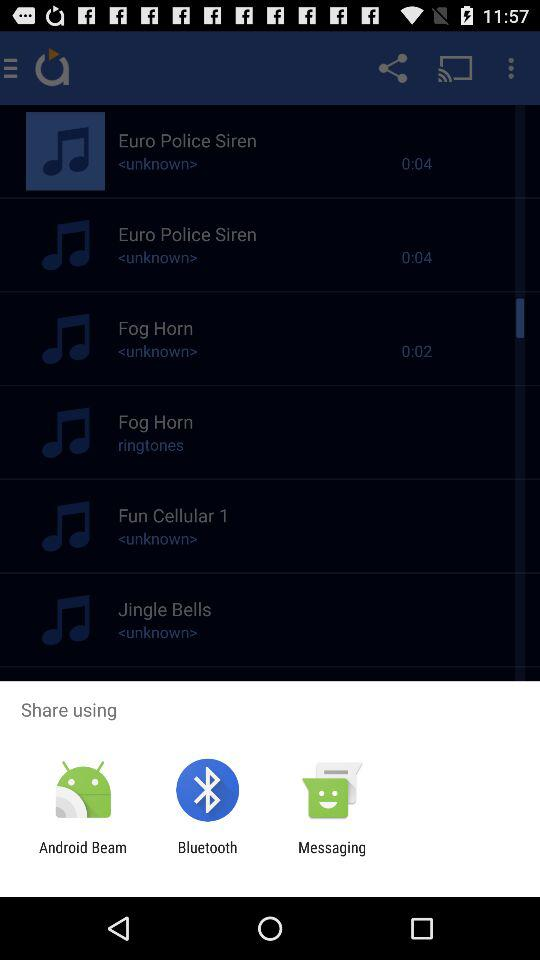Through which app can I share? You can share through "Android Beam", "Bluetooth" and "Messaging". 